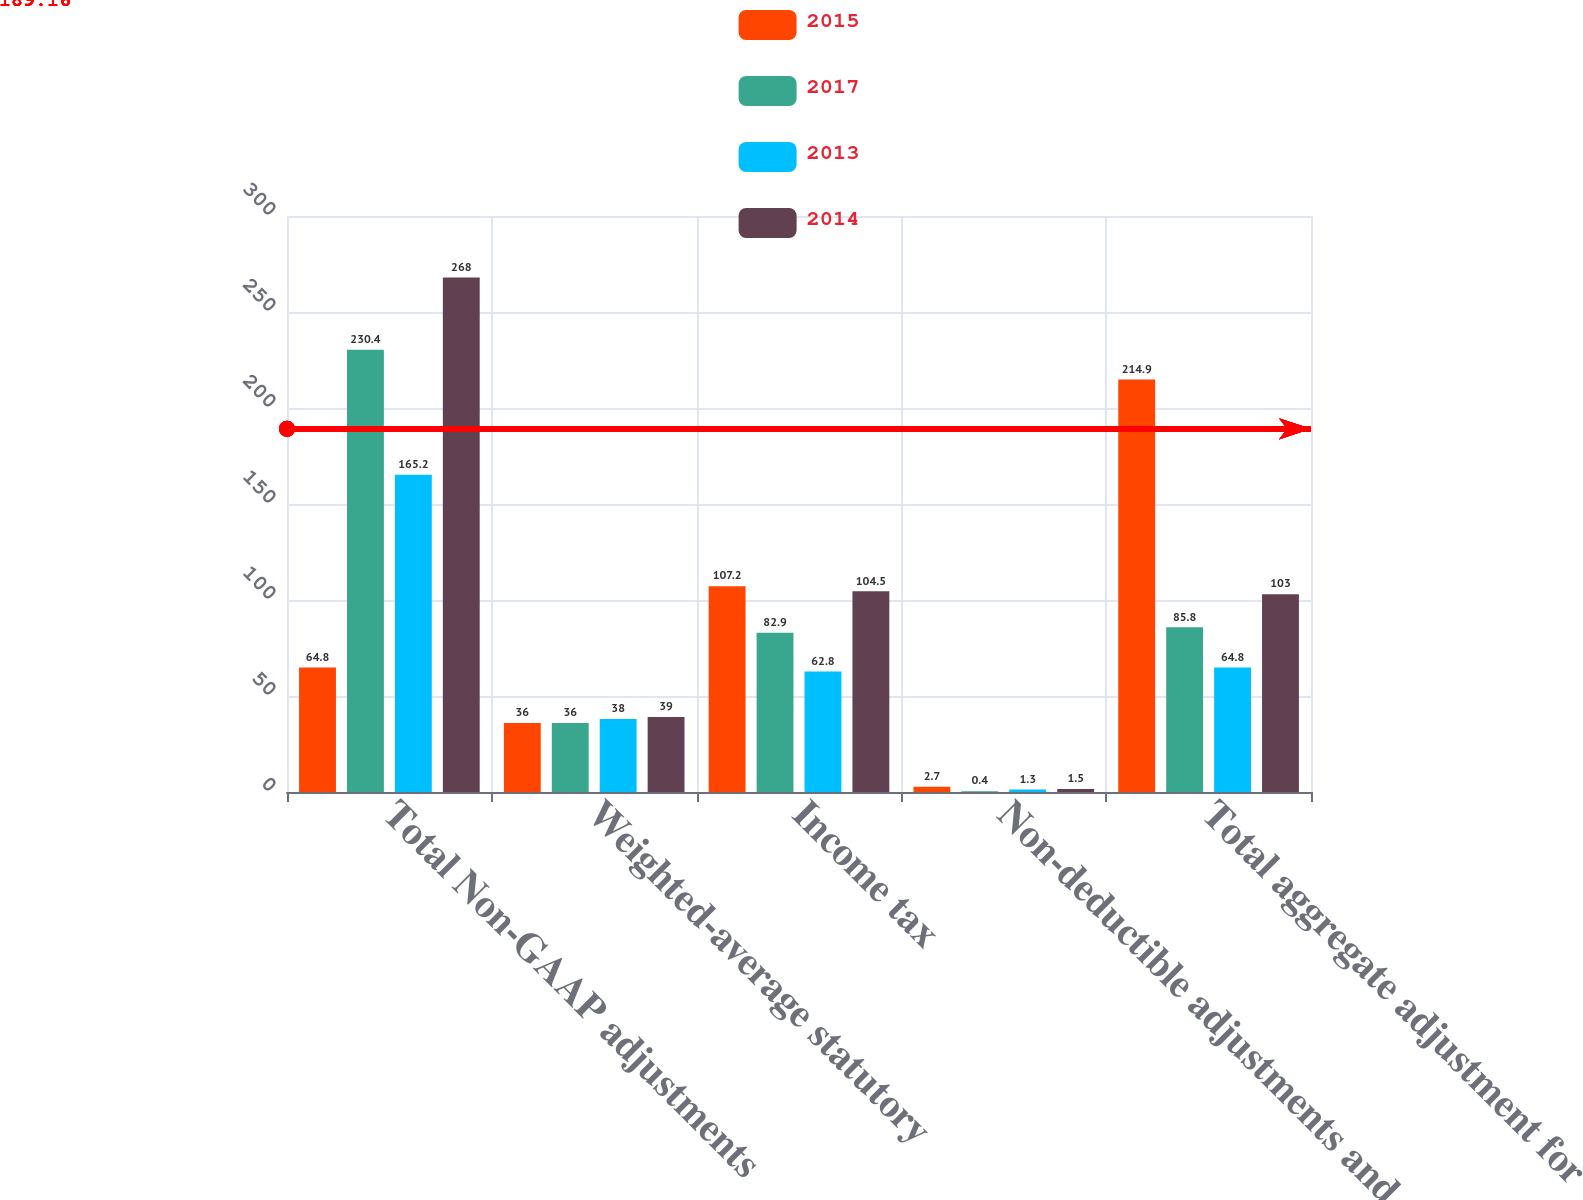Convert chart to OTSL. <chart><loc_0><loc_0><loc_500><loc_500><stacked_bar_chart><ecel><fcel>Total Non-GAAP adjustments<fcel>Weighted-average statutory<fcel>Income tax<fcel>Non-deductible adjustments and<fcel>Total aggregate adjustment for<nl><fcel>2015<fcel>64.8<fcel>36<fcel>107.2<fcel>2.7<fcel>214.9<nl><fcel>2017<fcel>230.4<fcel>36<fcel>82.9<fcel>0.4<fcel>85.8<nl><fcel>2013<fcel>165.2<fcel>38<fcel>62.8<fcel>1.3<fcel>64.8<nl><fcel>2014<fcel>268<fcel>39<fcel>104.5<fcel>1.5<fcel>103<nl></chart> 